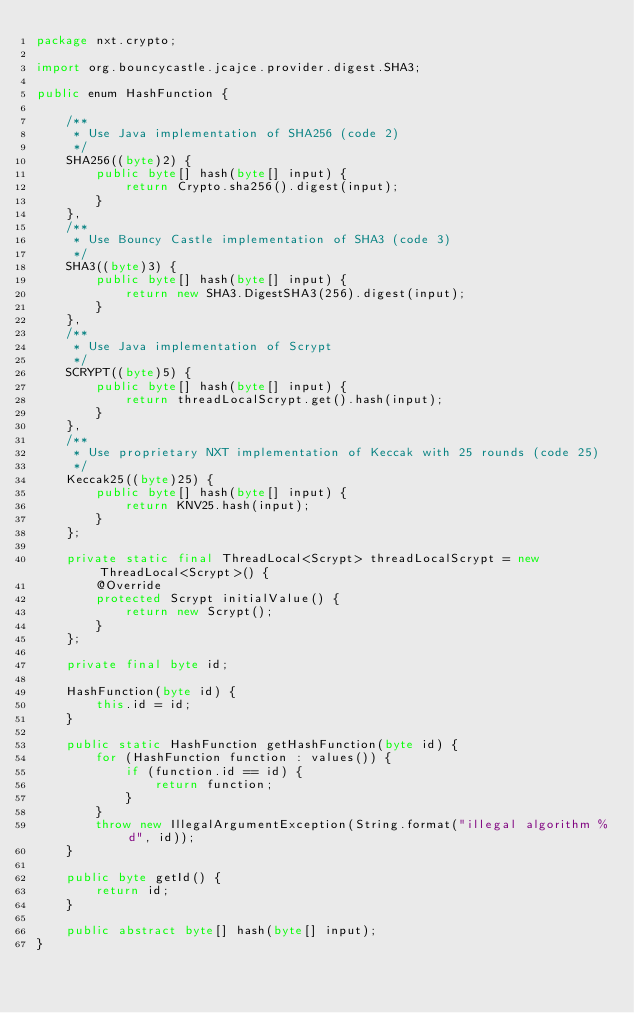<code> <loc_0><loc_0><loc_500><loc_500><_Java_>package nxt.crypto;

import org.bouncycastle.jcajce.provider.digest.SHA3;

public enum HashFunction {

    /**
     * Use Java implementation of SHA256 (code 2)
     */
    SHA256((byte)2) {
        public byte[] hash(byte[] input) {
            return Crypto.sha256().digest(input);
        }
    },
    /**
     * Use Bouncy Castle implementation of SHA3 (code 3)
     */
    SHA3((byte)3) {
        public byte[] hash(byte[] input) {
            return new SHA3.DigestSHA3(256).digest(input);
        }
    },
    /**
     * Use Java implementation of Scrypt
     */
    SCRYPT((byte)5) {
        public byte[] hash(byte[] input) {
            return threadLocalScrypt.get().hash(input);
        }
    },
    /**
     * Use proprietary NXT implementation of Keccak with 25 rounds (code 25)
     */
    Keccak25((byte)25) {
        public byte[] hash(byte[] input) {
            return KNV25.hash(input);
        }
    };

    private static final ThreadLocal<Scrypt> threadLocalScrypt = new ThreadLocal<Scrypt>() {
        @Override
        protected Scrypt initialValue() {
            return new Scrypt();
        }
    };

    private final byte id;

    HashFunction(byte id) {
        this.id = id;
    }

    public static HashFunction getHashFunction(byte id) {
        for (HashFunction function : values()) {
            if (function.id == id) {
                return function;
            }
        }
        throw new IllegalArgumentException(String.format("illegal algorithm %d", id));
    }

    public byte getId() {
        return id;
    }

    public abstract byte[] hash(byte[] input);
}
</code> 